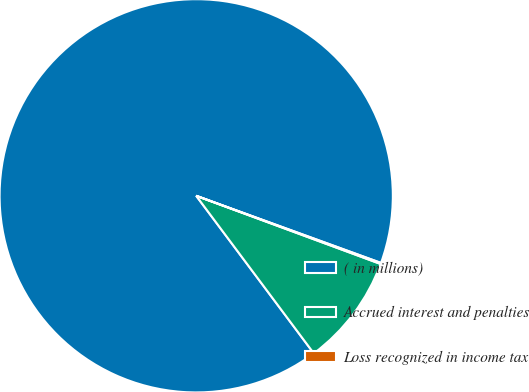Convert chart to OTSL. <chart><loc_0><loc_0><loc_500><loc_500><pie_chart><fcel>( in millions)<fcel>Accrued interest and penalties<fcel>Loss recognized in income tax<nl><fcel>90.75%<fcel>9.16%<fcel>0.09%<nl></chart> 